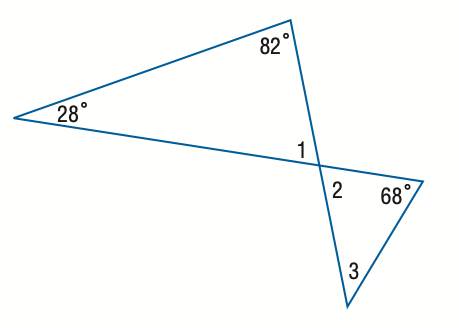Answer the mathemtical geometry problem and directly provide the correct option letter.
Question: Find the measure of \angle 1.
Choices: A: 68 B: 70 C: 70 D: 82 B 